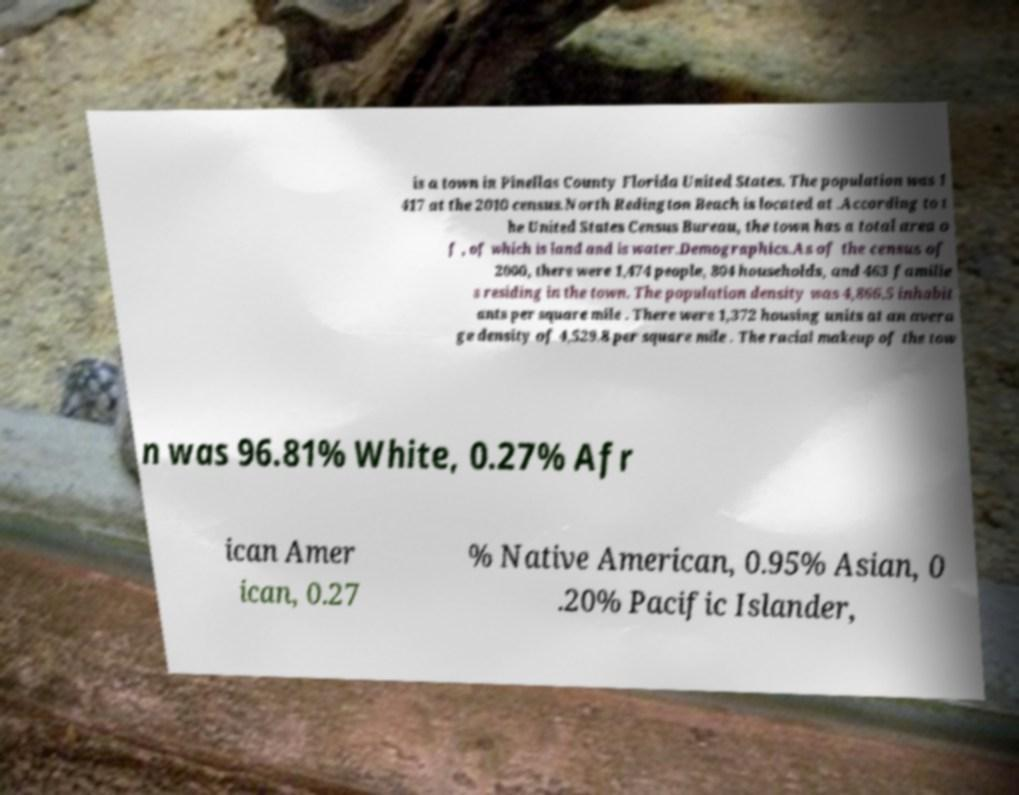I need the written content from this picture converted into text. Can you do that? is a town in Pinellas County Florida United States. The population was 1 417 at the 2010 census.North Redington Beach is located at .According to t he United States Census Bureau, the town has a total area o f , of which is land and is water.Demographics.As of the census of 2000, there were 1,474 people, 804 households, and 463 familie s residing in the town. The population density was 4,866.5 inhabit ants per square mile . There were 1,372 housing units at an avera ge density of 4,529.8 per square mile . The racial makeup of the tow n was 96.81% White, 0.27% Afr ican Amer ican, 0.27 % Native American, 0.95% Asian, 0 .20% Pacific Islander, 